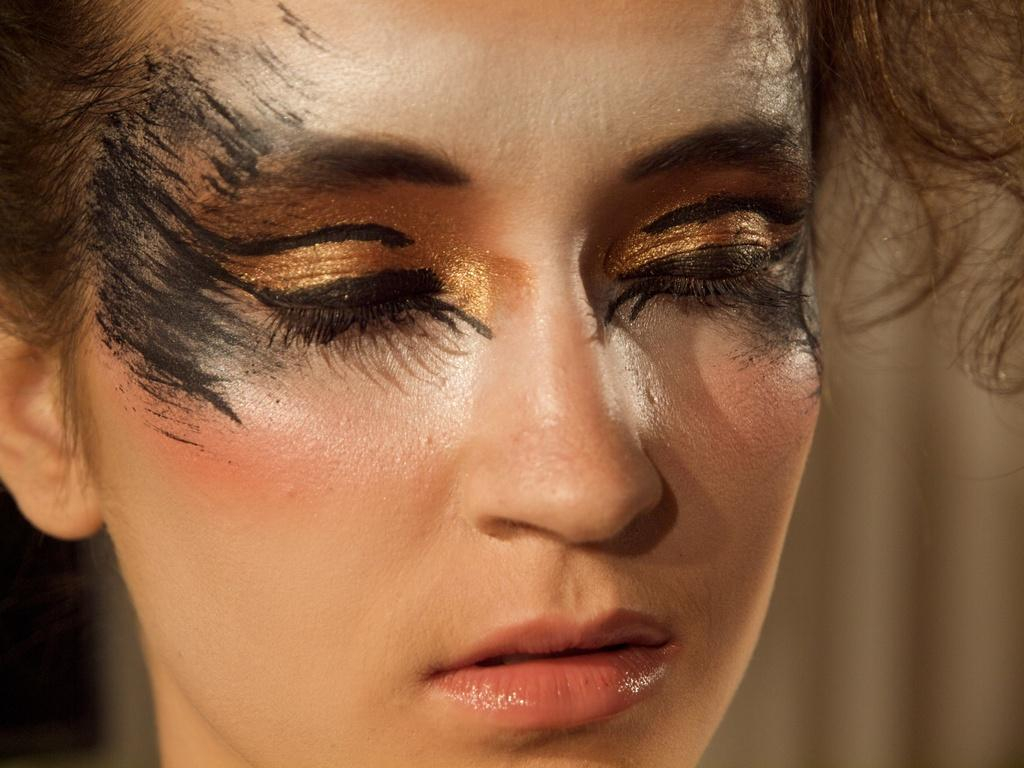Who is present in the image? There is a woman in the image. What type of wine is the woman drinking in the image? There is no wine present in the image; it only features a woman. Is the woman in jail in the image? There is no indication of a jail or any confinement in the image, and it only features a woman. 